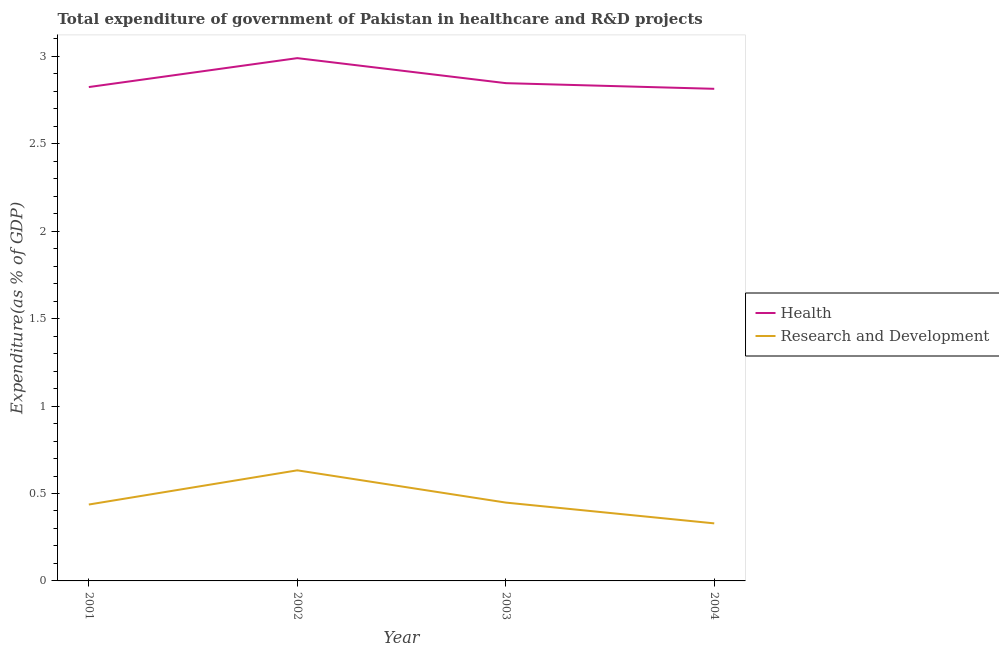How many different coloured lines are there?
Offer a very short reply. 2. What is the expenditure in r&d in 2003?
Ensure brevity in your answer.  0.45. Across all years, what is the maximum expenditure in r&d?
Keep it short and to the point. 0.63. Across all years, what is the minimum expenditure in r&d?
Provide a succinct answer. 0.33. In which year was the expenditure in healthcare maximum?
Provide a short and direct response. 2002. In which year was the expenditure in healthcare minimum?
Ensure brevity in your answer.  2004. What is the total expenditure in r&d in the graph?
Ensure brevity in your answer.  1.85. What is the difference between the expenditure in healthcare in 2002 and that in 2003?
Make the answer very short. 0.14. What is the difference between the expenditure in r&d in 2004 and the expenditure in healthcare in 2002?
Your response must be concise. -2.66. What is the average expenditure in r&d per year?
Ensure brevity in your answer.  0.46. In the year 2001, what is the difference between the expenditure in r&d and expenditure in healthcare?
Your answer should be very brief. -2.39. What is the ratio of the expenditure in healthcare in 2002 to that in 2003?
Your answer should be compact. 1.05. What is the difference between the highest and the second highest expenditure in healthcare?
Offer a very short reply. 0.14. What is the difference between the highest and the lowest expenditure in r&d?
Give a very brief answer. 0.3. Is the sum of the expenditure in healthcare in 2001 and 2004 greater than the maximum expenditure in r&d across all years?
Ensure brevity in your answer.  Yes. Does the expenditure in healthcare monotonically increase over the years?
Offer a terse response. No. Is the expenditure in r&d strictly greater than the expenditure in healthcare over the years?
Give a very brief answer. No. Is the expenditure in r&d strictly less than the expenditure in healthcare over the years?
Keep it short and to the point. Yes. How many lines are there?
Provide a succinct answer. 2. What is the difference between two consecutive major ticks on the Y-axis?
Give a very brief answer. 0.5. Are the values on the major ticks of Y-axis written in scientific E-notation?
Make the answer very short. No. How many legend labels are there?
Offer a terse response. 2. What is the title of the graph?
Your answer should be compact. Total expenditure of government of Pakistan in healthcare and R&D projects. Does "Male entrants" appear as one of the legend labels in the graph?
Offer a terse response. No. What is the label or title of the Y-axis?
Your answer should be very brief. Expenditure(as % of GDP). What is the Expenditure(as % of GDP) of Health in 2001?
Give a very brief answer. 2.82. What is the Expenditure(as % of GDP) of Research and Development in 2001?
Provide a short and direct response. 0.44. What is the Expenditure(as % of GDP) of Health in 2002?
Offer a terse response. 2.99. What is the Expenditure(as % of GDP) in Research and Development in 2002?
Ensure brevity in your answer.  0.63. What is the Expenditure(as % of GDP) of Health in 2003?
Give a very brief answer. 2.85. What is the Expenditure(as % of GDP) of Research and Development in 2003?
Your answer should be compact. 0.45. What is the Expenditure(as % of GDP) of Health in 2004?
Provide a succinct answer. 2.81. What is the Expenditure(as % of GDP) of Research and Development in 2004?
Keep it short and to the point. 0.33. Across all years, what is the maximum Expenditure(as % of GDP) of Health?
Offer a terse response. 2.99. Across all years, what is the maximum Expenditure(as % of GDP) of Research and Development?
Your answer should be compact. 0.63. Across all years, what is the minimum Expenditure(as % of GDP) in Health?
Your answer should be very brief. 2.81. Across all years, what is the minimum Expenditure(as % of GDP) in Research and Development?
Make the answer very short. 0.33. What is the total Expenditure(as % of GDP) in Health in the graph?
Offer a very short reply. 11.48. What is the total Expenditure(as % of GDP) in Research and Development in the graph?
Offer a very short reply. 1.85. What is the difference between the Expenditure(as % of GDP) of Health in 2001 and that in 2002?
Offer a very short reply. -0.17. What is the difference between the Expenditure(as % of GDP) in Research and Development in 2001 and that in 2002?
Make the answer very short. -0.2. What is the difference between the Expenditure(as % of GDP) in Health in 2001 and that in 2003?
Give a very brief answer. -0.02. What is the difference between the Expenditure(as % of GDP) in Research and Development in 2001 and that in 2003?
Provide a short and direct response. -0.01. What is the difference between the Expenditure(as % of GDP) of Research and Development in 2001 and that in 2004?
Provide a short and direct response. 0.11. What is the difference between the Expenditure(as % of GDP) in Health in 2002 and that in 2003?
Ensure brevity in your answer.  0.14. What is the difference between the Expenditure(as % of GDP) in Research and Development in 2002 and that in 2003?
Offer a terse response. 0.18. What is the difference between the Expenditure(as % of GDP) of Health in 2002 and that in 2004?
Ensure brevity in your answer.  0.18. What is the difference between the Expenditure(as % of GDP) of Research and Development in 2002 and that in 2004?
Provide a succinct answer. 0.3. What is the difference between the Expenditure(as % of GDP) of Health in 2003 and that in 2004?
Offer a very short reply. 0.03. What is the difference between the Expenditure(as % of GDP) of Research and Development in 2003 and that in 2004?
Give a very brief answer. 0.12. What is the difference between the Expenditure(as % of GDP) in Health in 2001 and the Expenditure(as % of GDP) in Research and Development in 2002?
Provide a short and direct response. 2.19. What is the difference between the Expenditure(as % of GDP) of Health in 2001 and the Expenditure(as % of GDP) of Research and Development in 2003?
Keep it short and to the point. 2.38. What is the difference between the Expenditure(as % of GDP) of Health in 2001 and the Expenditure(as % of GDP) of Research and Development in 2004?
Provide a short and direct response. 2.5. What is the difference between the Expenditure(as % of GDP) of Health in 2002 and the Expenditure(as % of GDP) of Research and Development in 2003?
Offer a very short reply. 2.54. What is the difference between the Expenditure(as % of GDP) in Health in 2002 and the Expenditure(as % of GDP) in Research and Development in 2004?
Offer a very short reply. 2.66. What is the difference between the Expenditure(as % of GDP) in Health in 2003 and the Expenditure(as % of GDP) in Research and Development in 2004?
Provide a succinct answer. 2.52. What is the average Expenditure(as % of GDP) of Health per year?
Provide a succinct answer. 2.87. What is the average Expenditure(as % of GDP) in Research and Development per year?
Your response must be concise. 0.46. In the year 2001, what is the difference between the Expenditure(as % of GDP) in Health and Expenditure(as % of GDP) in Research and Development?
Your response must be concise. 2.39. In the year 2002, what is the difference between the Expenditure(as % of GDP) in Health and Expenditure(as % of GDP) in Research and Development?
Ensure brevity in your answer.  2.36. In the year 2003, what is the difference between the Expenditure(as % of GDP) in Health and Expenditure(as % of GDP) in Research and Development?
Ensure brevity in your answer.  2.4. In the year 2004, what is the difference between the Expenditure(as % of GDP) in Health and Expenditure(as % of GDP) in Research and Development?
Your answer should be compact. 2.49. What is the ratio of the Expenditure(as % of GDP) of Health in 2001 to that in 2002?
Keep it short and to the point. 0.94. What is the ratio of the Expenditure(as % of GDP) of Research and Development in 2001 to that in 2002?
Your response must be concise. 0.69. What is the ratio of the Expenditure(as % of GDP) in Health in 2001 to that in 2003?
Make the answer very short. 0.99. What is the ratio of the Expenditure(as % of GDP) of Research and Development in 2001 to that in 2003?
Give a very brief answer. 0.98. What is the ratio of the Expenditure(as % of GDP) in Health in 2001 to that in 2004?
Your answer should be very brief. 1. What is the ratio of the Expenditure(as % of GDP) of Research and Development in 2001 to that in 2004?
Your answer should be compact. 1.33. What is the ratio of the Expenditure(as % of GDP) in Health in 2002 to that in 2003?
Offer a terse response. 1.05. What is the ratio of the Expenditure(as % of GDP) in Research and Development in 2002 to that in 2003?
Provide a short and direct response. 1.41. What is the ratio of the Expenditure(as % of GDP) of Health in 2002 to that in 2004?
Your answer should be compact. 1.06. What is the ratio of the Expenditure(as % of GDP) in Research and Development in 2002 to that in 2004?
Ensure brevity in your answer.  1.92. What is the ratio of the Expenditure(as % of GDP) in Health in 2003 to that in 2004?
Offer a very short reply. 1.01. What is the ratio of the Expenditure(as % of GDP) in Research and Development in 2003 to that in 2004?
Provide a short and direct response. 1.36. What is the difference between the highest and the second highest Expenditure(as % of GDP) in Health?
Ensure brevity in your answer.  0.14. What is the difference between the highest and the second highest Expenditure(as % of GDP) of Research and Development?
Offer a terse response. 0.18. What is the difference between the highest and the lowest Expenditure(as % of GDP) of Health?
Provide a succinct answer. 0.18. What is the difference between the highest and the lowest Expenditure(as % of GDP) of Research and Development?
Keep it short and to the point. 0.3. 